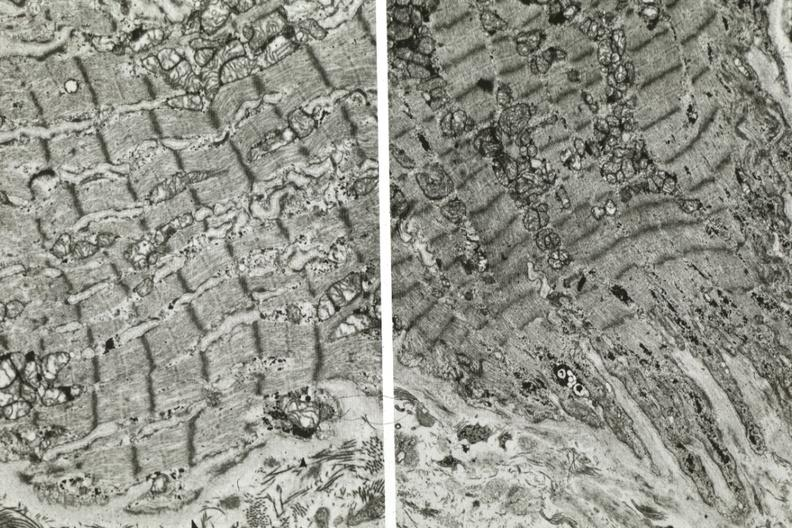what does electron micrographs demonstrating fiber other frame shows dilated sarcoplasmic reticulum?
Answer the question using a single word or phrase. Not connect with another 